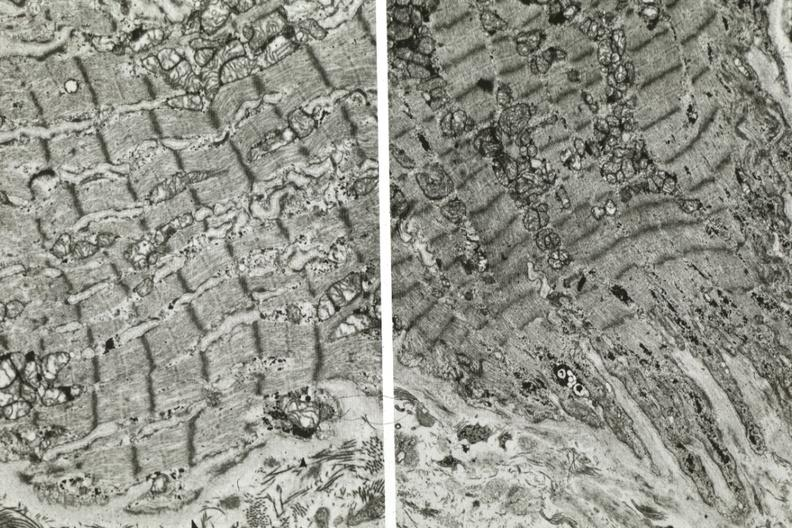what does electron micrographs demonstrating fiber other frame shows dilated sarcoplasmic reticulum?
Answer the question using a single word or phrase. Not connect with another 